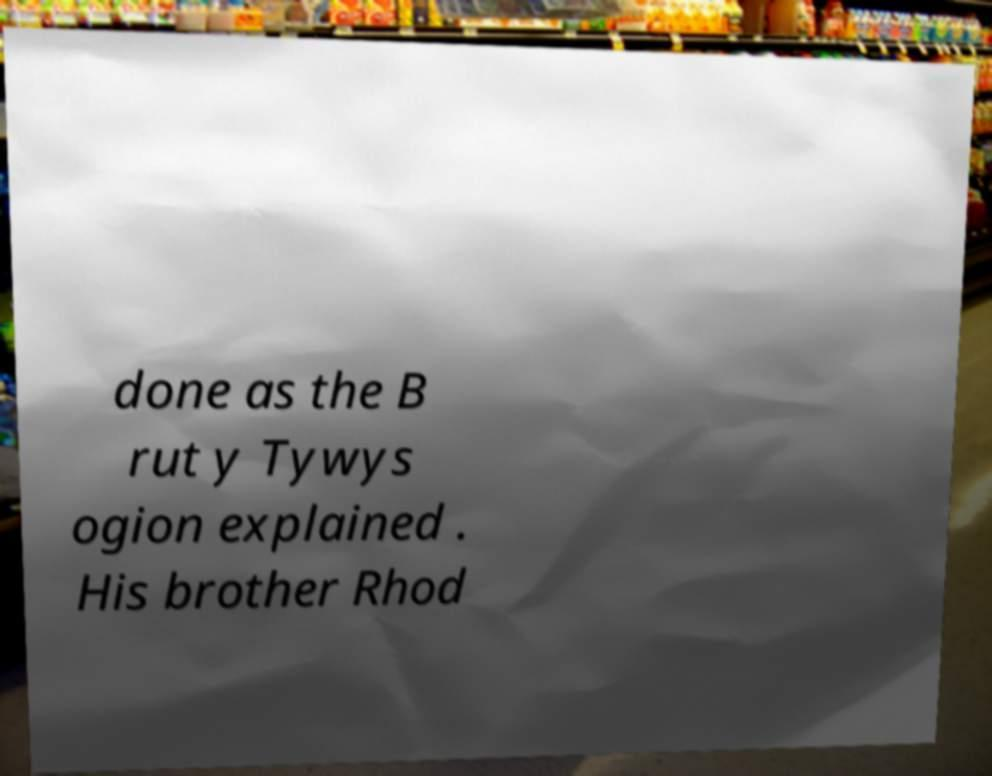Could you extract and type out the text from this image? done as the B rut y Tywys ogion explained . His brother Rhod 